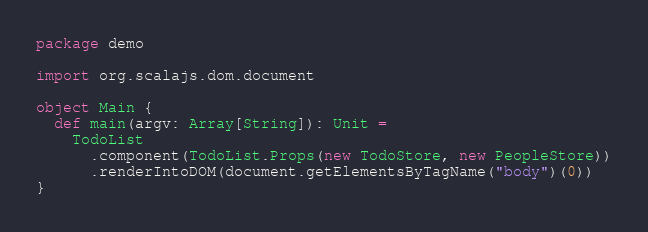<code> <loc_0><loc_0><loc_500><loc_500><_Scala_>package demo

import org.scalajs.dom.document

object Main {
  def main(argv: Array[String]): Unit =
    TodoList
      .component(TodoList.Props(new TodoStore, new PeopleStore))
      .renderIntoDOM(document.getElementsByTagName("body")(0))
}
</code> 